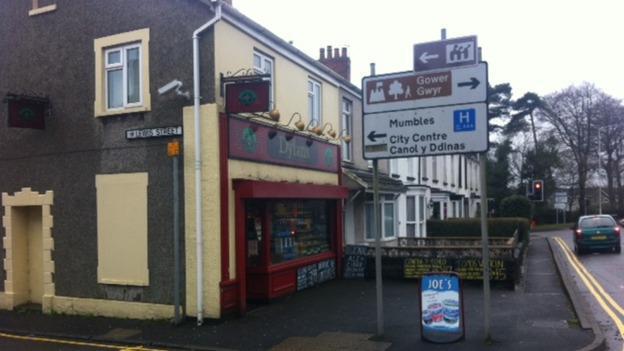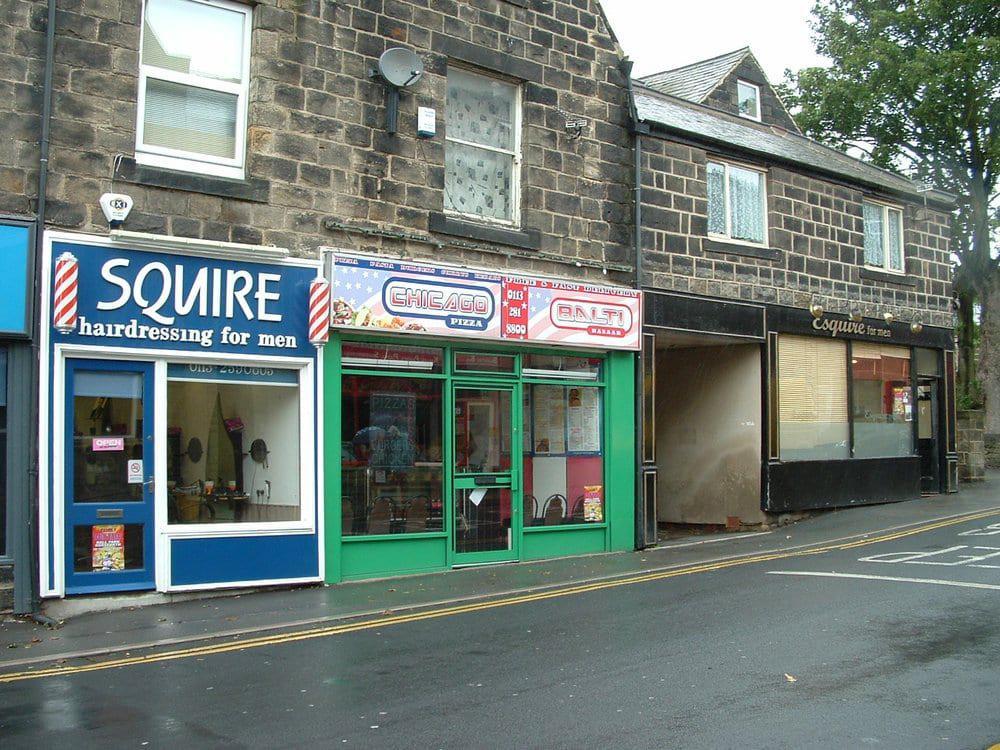The first image is the image on the left, the second image is the image on the right. Assess this claim about the two images: "A truck is visible in one image, and at least one car is visible in each image.". Correct or not? Answer yes or no. No. 